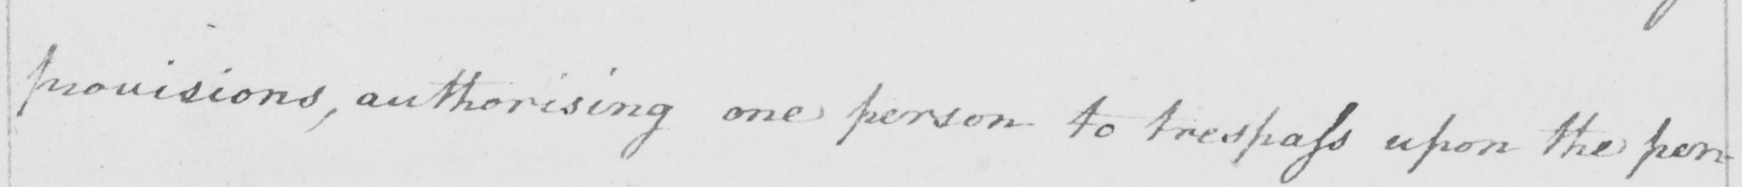Can you read and transcribe this handwriting? provisions , authorising one person to trespass upon the per- 